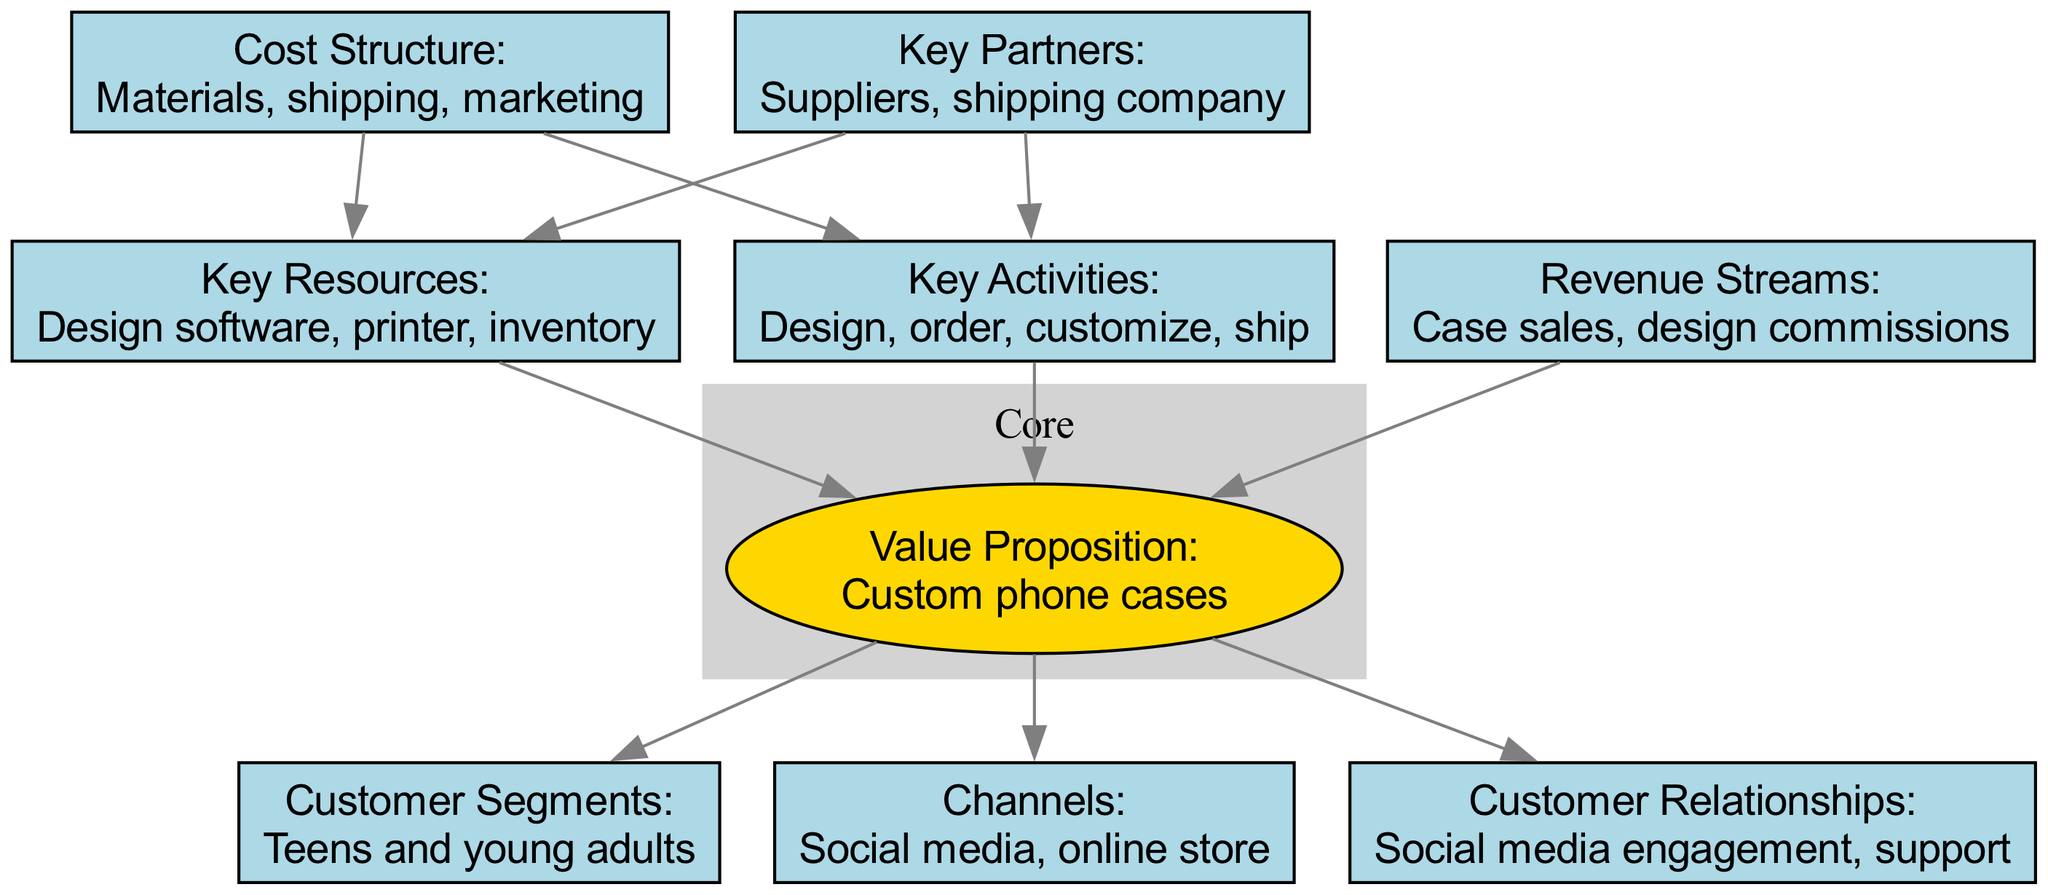What is the value proposition of the business? The value proposition is stated clearly in the diagram and is labeled "Value Proposition." It is described as "Custom phone cases."
Answer: Custom phone cases How many customer segments are identified in the diagram? The diagram lists customer segments in a node labeled "Customer Segments." In this case, there is one customer segment identified: "Teens and young adults."
Answer: 1 What are the key activities listed? The diagram has a node labeled "Key Activities," which includes a description of the activities performed by the business. It clearly lists four activities: "Design, order, customize, ship."
Answer: Design, order, customize, ship Which element is connected to both "Key Partners" and "Revenue Streams"? To determine this, we look at the connections in the diagram. "Key Partners" is connected to "Key Activities" and "Key Resources" while "Revenue Streams" is only connected to the "Value Proposition." The only common connection for both is "Value Proposition."
Answer: Value Proposition What are the two main revenue streams identified? The "Revenue Streams" node in the diagram specifies what income sources the business has. It lists two revenue sources: "Case sales" and "design commissions."
Answer: Case sales, design commissions How many key resources are associated with the business? The diagram shows key resources in the "Key Resources" node, which lists three specific resources: "Design software, printer, inventory." Therefore, we can count the total number of resources mentioned.
Answer: 3 What is the purpose of social media in this business model? The "Channels" node features "social media" as a key channel for the business. This indicates that social media is used primarily for marketing and engaging with customers.
Answer: Marketing and engagement What is the cost structure related to? The node labeled "Cost Structure" specifies that costs are categorized as "Materials, shipping, marketing." This represents the various expenses involved in running the business.
Answer: Materials, shipping, marketing Which section of the canvas focuses on customer engagement? Looking closely, the "Customer Relationships" section is specified in the diagram, highlighting how the business interacts with its customers, particularly through "Social media engagement, support."
Answer: Customer Relationships 